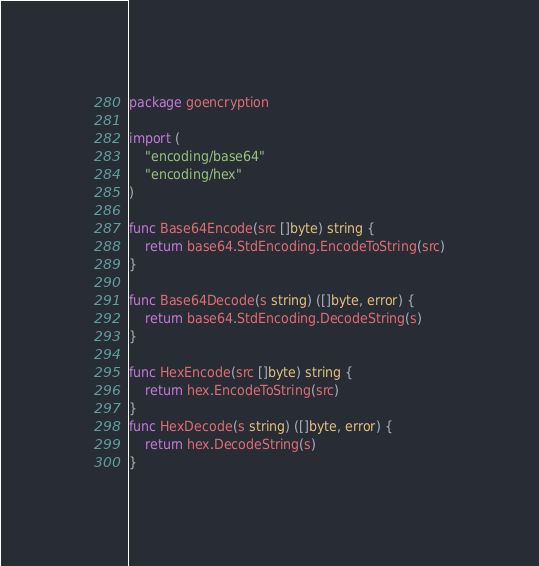Convert code to text. <code><loc_0><loc_0><loc_500><loc_500><_Go_>package goencryption

import (
	"encoding/base64"
	"encoding/hex"
)

func Base64Encode(src []byte) string {
	return base64.StdEncoding.EncodeToString(src)
}

func Base64Decode(s string) ([]byte, error) {
	return base64.StdEncoding.DecodeString(s)
}

func HexEncode(src []byte) string {
	return hex.EncodeToString(src)
}
func HexDecode(s string) ([]byte, error) {
	return hex.DecodeString(s)
}</code> 